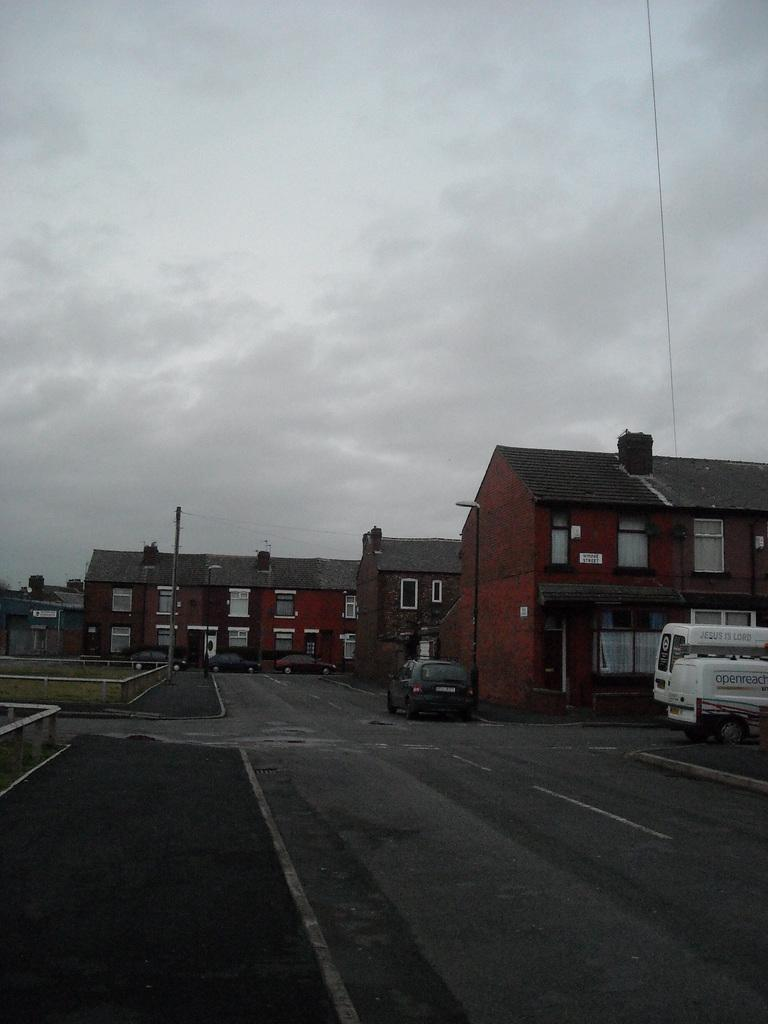What is present on the road in the image? There are vehicles on the road in the image. What can be seen in the background of the image? There are buildings in the background of the image. What is the color of the buildings? The buildings are in brown color. What is visible above the buildings and vehicles in the image? The sky is visible in the image. What colors are present in the sky? The sky is in white and gray color. How many people are present in the crowd in the image? There is no crowd present in the image; it features vehicles on the road and buildings in the background. What type of society is depicted in the image? The image does not depict a society; it shows vehicles, buildings, and the sky. 